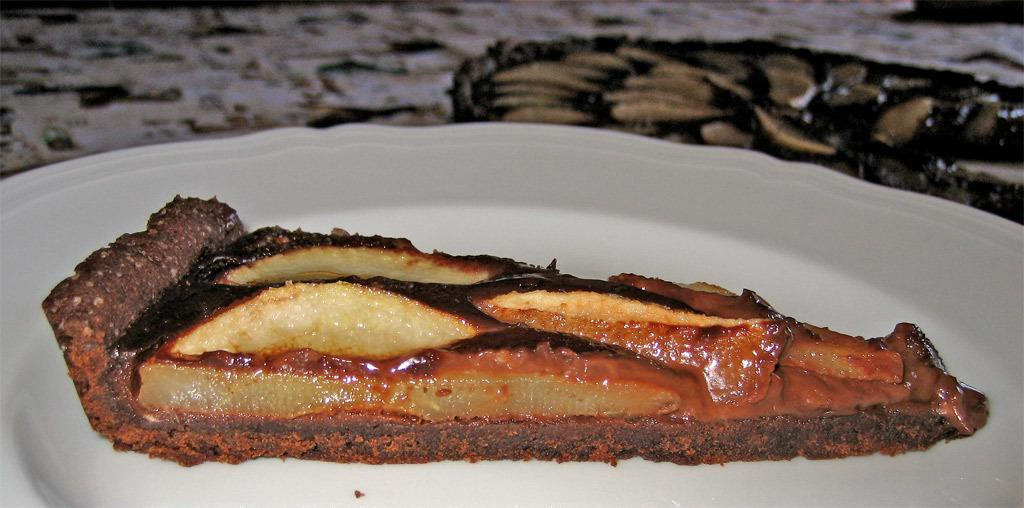What is on the plate in the image? There is food on the plate in the image. Can you describe the background of the image? The background of the image is blurry. What type of nut is being cracked by the flame in the image? There is no nut or flame present in the image. 